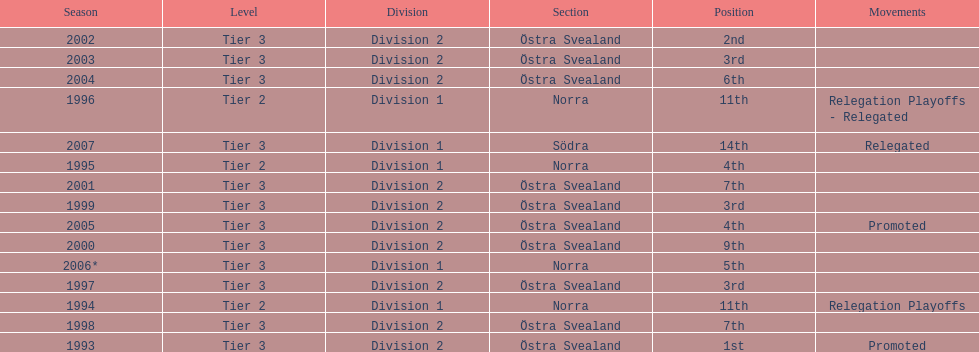They placed third in 2003. when did they place third before that? 1999. 